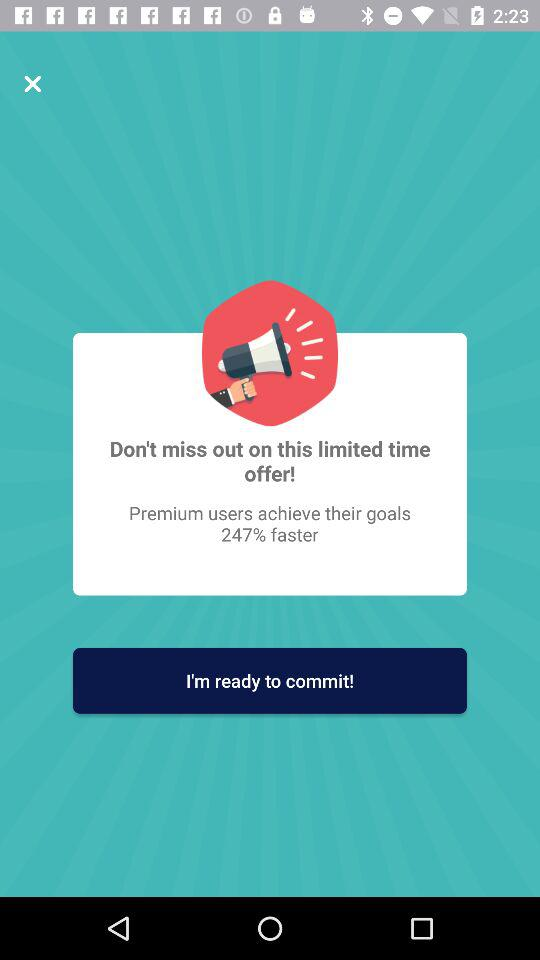How much faster do premium users achieve their goals?
Answer the question using a single word or phrase. 247% 